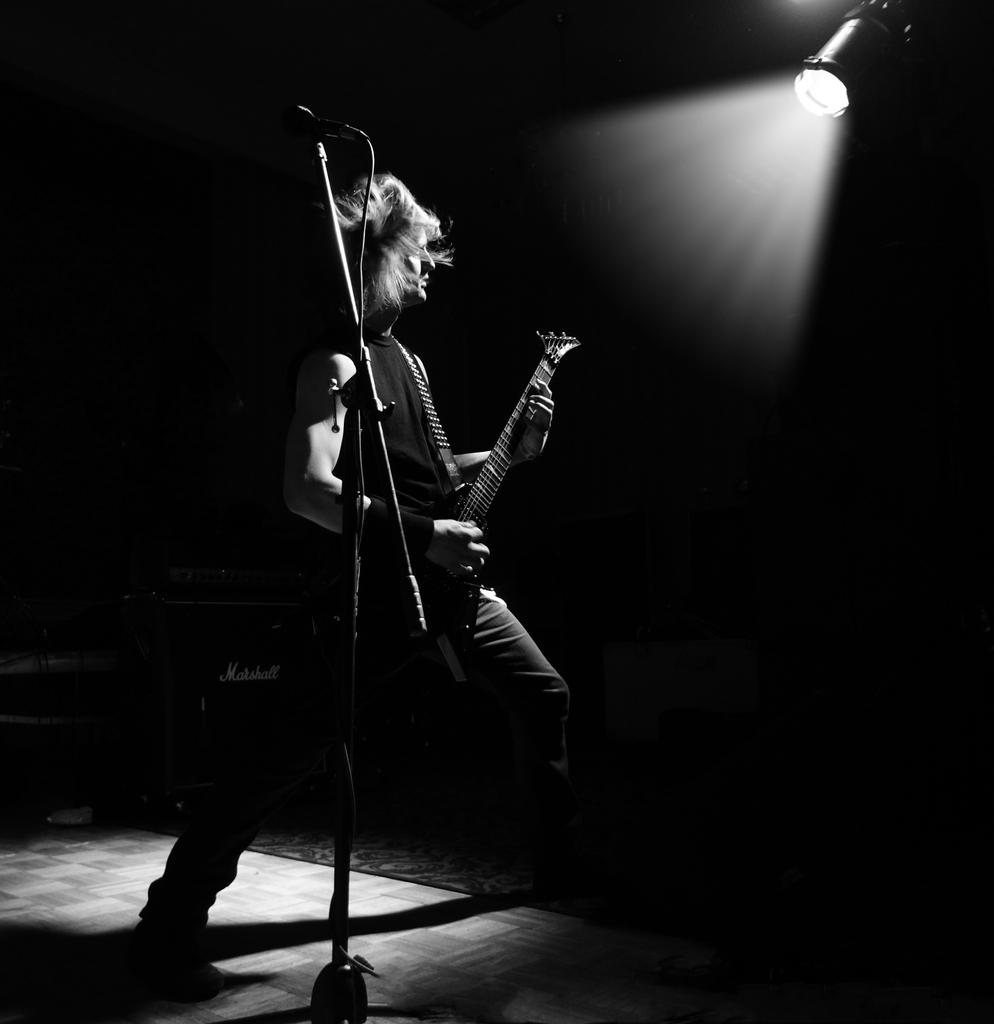What is the main subject of the image? There is a man standing in the image. What is the man wearing? The man is wearing a guitar. What object is in front of the man? There is a microphone on a stand in front of the man. What can be seen in the top right corner of the image? There is a spotlight in the top right corner of the image. How would you describe the background of the background of the image? The background of the image is dark. What type of leaf is falling from the man's guitar in the image? There is no leaf present in the image, and the man is not playing a guitar that would have leaves. 